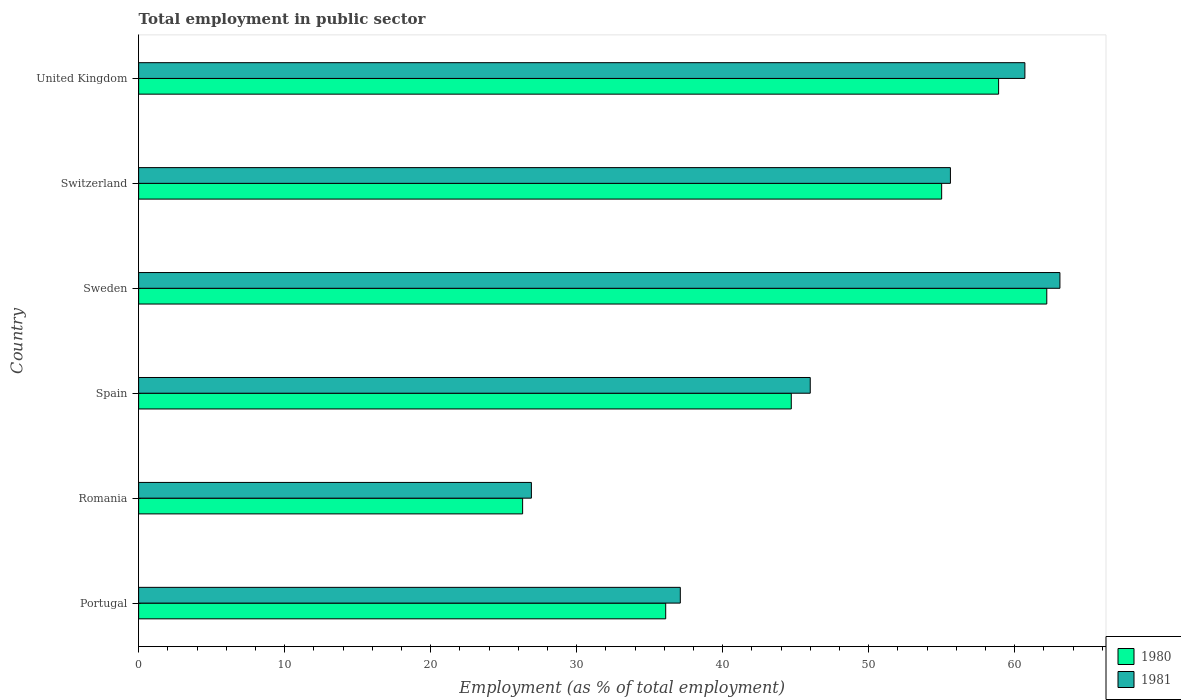How many different coloured bars are there?
Ensure brevity in your answer.  2. Are the number of bars on each tick of the Y-axis equal?
Your answer should be very brief. Yes. How many bars are there on the 6th tick from the top?
Give a very brief answer. 2. How many bars are there on the 5th tick from the bottom?
Offer a terse response. 2. What is the label of the 5th group of bars from the top?
Provide a succinct answer. Romania. In how many cases, is the number of bars for a given country not equal to the number of legend labels?
Provide a succinct answer. 0. What is the employment in public sector in 1980 in Spain?
Offer a terse response. 44.7. Across all countries, what is the maximum employment in public sector in 1981?
Make the answer very short. 63.1. Across all countries, what is the minimum employment in public sector in 1981?
Keep it short and to the point. 26.9. In which country was the employment in public sector in 1981 minimum?
Ensure brevity in your answer.  Romania. What is the total employment in public sector in 1980 in the graph?
Keep it short and to the point. 283.2. What is the difference between the employment in public sector in 1980 in Romania and that in Sweden?
Your response must be concise. -35.9. What is the difference between the employment in public sector in 1981 in Switzerland and the employment in public sector in 1980 in Romania?
Offer a very short reply. 29.3. What is the average employment in public sector in 1980 per country?
Your answer should be very brief. 47.2. What is the difference between the employment in public sector in 1981 and employment in public sector in 1980 in United Kingdom?
Give a very brief answer. 1.8. What is the ratio of the employment in public sector in 1981 in Spain to that in Switzerland?
Make the answer very short. 0.83. Is the employment in public sector in 1981 in Switzerland less than that in United Kingdom?
Provide a short and direct response. Yes. What is the difference between the highest and the second highest employment in public sector in 1980?
Keep it short and to the point. 3.3. What is the difference between the highest and the lowest employment in public sector in 1980?
Offer a very short reply. 35.9. In how many countries, is the employment in public sector in 1981 greater than the average employment in public sector in 1981 taken over all countries?
Provide a short and direct response. 3. What does the 2nd bar from the top in United Kingdom represents?
Provide a succinct answer. 1980. What is the difference between two consecutive major ticks on the X-axis?
Your response must be concise. 10. Does the graph contain any zero values?
Keep it short and to the point. No. How are the legend labels stacked?
Give a very brief answer. Vertical. What is the title of the graph?
Provide a short and direct response. Total employment in public sector. Does "1984" appear as one of the legend labels in the graph?
Keep it short and to the point. No. What is the label or title of the X-axis?
Offer a terse response. Employment (as % of total employment). What is the Employment (as % of total employment) of 1980 in Portugal?
Make the answer very short. 36.1. What is the Employment (as % of total employment) in 1981 in Portugal?
Your answer should be compact. 37.1. What is the Employment (as % of total employment) of 1980 in Romania?
Keep it short and to the point. 26.3. What is the Employment (as % of total employment) of 1981 in Romania?
Provide a succinct answer. 26.9. What is the Employment (as % of total employment) of 1980 in Spain?
Provide a short and direct response. 44.7. What is the Employment (as % of total employment) in 1981 in Spain?
Your response must be concise. 46. What is the Employment (as % of total employment) in 1980 in Sweden?
Offer a terse response. 62.2. What is the Employment (as % of total employment) of 1981 in Sweden?
Your answer should be very brief. 63.1. What is the Employment (as % of total employment) in 1981 in Switzerland?
Ensure brevity in your answer.  55.6. What is the Employment (as % of total employment) of 1980 in United Kingdom?
Your answer should be very brief. 58.9. What is the Employment (as % of total employment) of 1981 in United Kingdom?
Ensure brevity in your answer.  60.7. Across all countries, what is the maximum Employment (as % of total employment) of 1980?
Keep it short and to the point. 62.2. Across all countries, what is the maximum Employment (as % of total employment) of 1981?
Give a very brief answer. 63.1. Across all countries, what is the minimum Employment (as % of total employment) of 1980?
Ensure brevity in your answer.  26.3. Across all countries, what is the minimum Employment (as % of total employment) of 1981?
Offer a very short reply. 26.9. What is the total Employment (as % of total employment) of 1980 in the graph?
Give a very brief answer. 283.2. What is the total Employment (as % of total employment) of 1981 in the graph?
Keep it short and to the point. 289.4. What is the difference between the Employment (as % of total employment) of 1981 in Portugal and that in Romania?
Ensure brevity in your answer.  10.2. What is the difference between the Employment (as % of total employment) of 1980 in Portugal and that in Spain?
Provide a succinct answer. -8.6. What is the difference between the Employment (as % of total employment) of 1981 in Portugal and that in Spain?
Your response must be concise. -8.9. What is the difference between the Employment (as % of total employment) in 1980 in Portugal and that in Sweden?
Your answer should be compact. -26.1. What is the difference between the Employment (as % of total employment) of 1980 in Portugal and that in Switzerland?
Provide a short and direct response. -18.9. What is the difference between the Employment (as % of total employment) in 1981 in Portugal and that in Switzerland?
Offer a very short reply. -18.5. What is the difference between the Employment (as % of total employment) in 1980 in Portugal and that in United Kingdom?
Provide a succinct answer. -22.8. What is the difference between the Employment (as % of total employment) of 1981 in Portugal and that in United Kingdom?
Ensure brevity in your answer.  -23.6. What is the difference between the Employment (as % of total employment) of 1980 in Romania and that in Spain?
Your response must be concise. -18.4. What is the difference between the Employment (as % of total employment) in 1981 in Romania and that in Spain?
Offer a terse response. -19.1. What is the difference between the Employment (as % of total employment) in 1980 in Romania and that in Sweden?
Give a very brief answer. -35.9. What is the difference between the Employment (as % of total employment) of 1981 in Romania and that in Sweden?
Provide a succinct answer. -36.2. What is the difference between the Employment (as % of total employment) in 1980 in Romania and that in Switzerland?
Your response must be concise. -28.7. What is the difference between the Employment (as % of total employment) of 1981 in Romania and that in Switzerland?
Your answer should be compact. -28.7. What is the difference between the Employment (as % of total employment) of 1980 in Romania and that in United Kingdom?
Keep it short and to the point. -32.6. What is the difference between the Employment (as % of total employment) of 1981 in Romania and that in United Kingdom?
Offer a terse response. -33.8. What is the difference between the Employment (as % of total employment) in 1980 in Spain and that in Sweden?
Your response must be concise. -17.5. What is the difference between the Employment (as % of total employment) in 1981 in Spain and that in Sweden?
Make the answer very short. -17.1. What is the difference between the Employment (as % of total employment) in 1980 in Spain and that in Switzerland?
Make the answer very short. -10.3. What is the difference between the Employment (as % of total employment) of 1981 in Spain and that in United Kingdom?
Offer a very short reply. -14.7. What is the difference between the Employment (as % of total employment) of 1980 in Sweden and that in United Kingdom?
Your answer should be compact. 3.3. What is the difference between the Employment (as % of total employment) in 1981 in Switzerland and that in United Kingdom?
Ensure brevity in your answer.  -5.1. What is the difference between the Employment (as % of total employment) of 1980 in Portugal and the Employment (as % of total employment) of 1981 in Spain?
Your answer should be compact. -9.9. What is the difference between the Employment (as % of total employment) in 1980 in Portugal and the Employment (as % of total employment) in 1981 in Sweden?
Make the answer very short. -27. What is the difference between the Employment (as % of total employment) of 1980 in Portugal and the Employment (as % of total employment) of 1981 in Switzerland?
Your answer should be very brief. -19.5. What is the difference between the Employment (as % of total employment) of 1980 in Portugal and the Employment (as % of total employment) of 1981 in United Kingdom?
Offer a very short reply. -24.6. What is the difference between the Employment (as % of total employment) in 1980 in Romania and the Employment (as % of total employment) in 1981 in Spain?
Ensure brevity in your answer.  -19.7. What is the difference between the Employment (as % of total employment) of 1980 in Romania and the Employment (as % of total employment) of 1981 in Sweden?
Provide a short and direct response. -36.8. What is the difference between the Employment (as % of total employment) of 1980 in Romania and the Employment (as % of total employment) of 1981 in Switzerland?
Keep it short and to the point. -29.3. What is the difference between the Employment (as % of total employment) of 1980 in Romania and the Employment (as % of total employment) of 1981 in United Kingdom?
Offer a terse response. -34.4. What is the difference between the Employment (as % of total employment) in 1980 in Spain and the Employment (as % of total employment) in 1981 in Sweden?
Ensure brevity in your answer.  -18.4. What is the difference between the Employment (as % of total employment) of 1980 in Spain and the Employment (as % of total employment) of 1981 in Switzerland?
Offer a very short reply. -10.9. What is the difference between the Employment (as % of total employment) in 1980 in Sweden and the Employment (as % of total employment) in 1981 in Switzerland?
Your answer should be compact. 6.6. What is the average Employment (as % of total employment) in 1980 per country?
Your answer should be very brief. 47.2. What is the average Employment (as % of total employment) of 1981 per country?
Provide a succinct answer. 48.23. What is the difference between the Employment (as % of total employment) of 1980 and Employment (as % of total employment) of 1981 in Portugal?
Your answer should be very brief. -1. What is the difference between the Employment (as % of total employment) of 1980 and Employment (as % of total employment) of 1981 in Romania?
Your answer should be compact. -0.6. What is the difference between the Employment (as % of total employment) in 1980 and Employment (as % of total employment) in 1981 in Switzerland?
Give a very brief answer. -0.6. What is the difference between the Employment (as % of total employment) in 1980 and Employment (as % of total employment) in 1981 in United Kingdom?
Keep it short and to the point. -1.8. What is the ratio of the Employment (as % of total employment) of 1980 in Portugal to that in Romania?
Provide a short and direct response. 1.37. What is the ratio of the Employment (as % of total employment) in 1981 in Portugal to that in Romania?
Your answer should be very brief. 1.38. What is the ratio of the Employment (as % of total employment) in 1980 in Portugal to that in Spain?
Your answer should be very brief. 0.81. What is the ratio of the Employment (as % of total employment) in 1981 in Portugal to that in Spain?
Your response must be concise. 0.81. What is the ratio of the Employment (as % of total employment) of 1980 in Portugal to that in Sweden?
Provide a succinct answer. 0.58. What is the ratio of the Employment (as % of total employment) in 1981 in Portugal to that in Sweden?
Keep it short and to the point. 0.59. What is the ratio of the Employment (as % of total employment) in 1980 in Portugal to that in Switzerland?
Give a very brief answer. 0.66. What is the ratio of the Employment (as % of total employment) in 1981 in Portugal to that in Switzerland?
Keep it short and to the point. 0.67. What is the ratio of the Employment (as % of total employment) of 1980 in Portugal to that in United Kingdom?
Offer a very short reply. 0.61. What is the ratio of the Employment (as % of total employment) of 1981 in Portugal to that in United Kingdom?
Provide a succinct answer. 0.61. What is the ratio of the Employment (as % of total employment) of 1980 in Romania to that in Spain?
Your answer should be compact. 0.59. What is the ratio of the Employment (as % of total employment) of 1981 in Romania to that in Spain?
Keep it short and to the point. 0.58. What is the ratio of the Employment (as % of total employment) in 1980 in Romania to that in Sweden?
Provide a succinct answer. 0.42. What is the ratio of the Employment (as % of total employment) of 1981 in Romania to that in Sweden?
Provide a succinct answer. 0.43. What is the ratio of the Employment (as % of total employment) of 1980 in Romania to that in Switzerland?
Ensure brevity in your answer.  0.48. What is the ratio of the Employment (as % of total employment) of 1981 in Romania to that in Switzerland?
Make the answer very short. 0.48. What is the ratio of the Employment (as % of total employment) in 1980 in Romania to that in United Kingdom?
Give a very brief answer. 0.45. What is the ratio of the Employment (as % of total employment) of 1981 in Romania to that in United Kingdom?
Ensure brevity in your answer.  0.44. What is the ratio of the Employment (as % of total employment) in 1980 in Spain to that in Sweden?
Your answer should be compact. 0.72. What is the ratio of the Employment (as % of total employment) in 1981 in Spain to that in Sweden?
Offer a very short reply. 0.73. What is the ratio of the Employment (as % of total employment) of 1980 in Spain to that in Switzerland?
Keep it short and to the point. 0.81. What is the ratio of the Employment (as % of total employment) in 1981 in Spain to that in Switzerland?
Provide a short and direct response. 0.83. What is the ratio of the Employment (as % of total employment) of 1980 in Spain to that in United Kingdom?
Provide a short and direct response. 0.76. What is the ratio of the Employment (as % of total employment) in 1981 in Spain to that in United Kingdom?
Make the answer very short. 0.76. What is the ratio of the Employment (as % of total employment) in 1980 in Sweden to that in Switzerland?
Ensure brevity in your answer.  1.13. What is the ratio of the Employment (as % of total employment) in 1981 in Sweden to that in Switzerland?
Give a very brief answer. 1.13. What is the ratio of the Employment (as % of total employment) in 1980 in Sweden to that in United Kingdom?
Your response must be concise. 1.06. What is the ratio of the Employment (as % of total employment) in 1981 in Sweden to that in United Kingdom?
Offer a very short reply. 1.04. What is the ratio of the Employment (as % of total employment) of 1980 in Switzerland to that in United Kingdom?
Ensure brevity in your answer.  0.93. What is the ratio of the Employment (as % of total employment) in 1981 in Switzerland to that in United Kingdom?
Ensure brevity in your answer.  0.92. What is the difference between the highest and the second highest Employment (as % of total employment) of 1980?
Your answer should be compact. 3.3. What is the difference between the highest and the lowest Employment (as % of total employment) of 1980?
Offer a terse response. 35.9. What is the difference between the highest and the lowest Employment (as % of total employment) in 1981?
Your response must be concise. 36.2. 